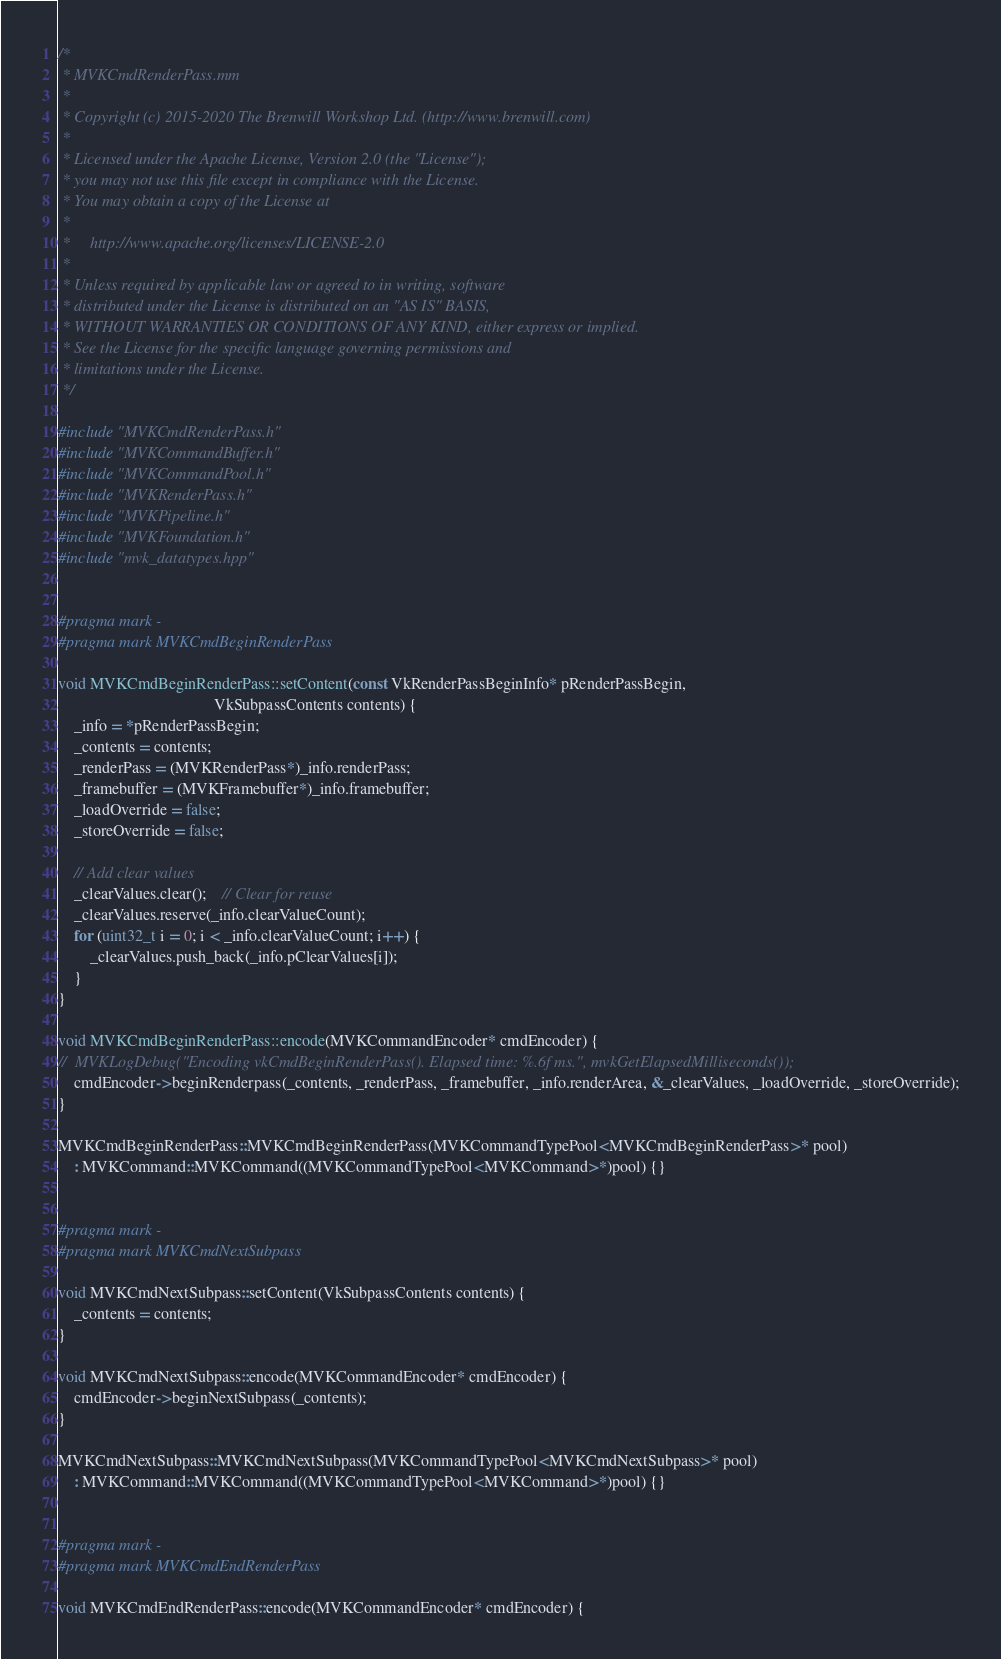Convert code to text. <code><loc_0><loc_0><loc_500><loc_500><_ObjectiveC_>/*
 * MVKCmdRenderPass.mm
 *
 * Copyright (c) 2015-2020 The Brenwill Workshop Ltd. (http://www.brenwill.com)
 *
 * Licensed under the Apache License, Version 2.0 (the "License");
 * you may not use this file except in compliance with the License.
 * You may obtain a copy of the License at
 * 
 *     http://www.apache.org/licenses/LICENSE-2.0
 * 
 * Unless required by applicable law or agreed to in writing, software
 * distributed under the License is distributed on an "AS IS" BASIS,
 * WITHOUT WARRANTIES OR CONDITIONS OF ANY KIND, either express or implied.
 * See the License for the specific language governing permissions and
 * limitations under the License.
 */

#include "MVKCmdRenderPass.h"
#include "MVKCommandBuffer.h"
#include "MVKCommandPool.h"
#include "MVKRenderPass.h"
#include "MVKPipeline.h"
#include "MVKFoundation.h"
#include "mvk_datatypes.hpp"


#pragma mark -
#pragma mark MVKCmdBeginRenderPass

void MVKCmdBeginRenderPass::setContent(const VkRenderPassBeginInfo* pRenderPassBegin,
									   VkSubpassContents contents) {
	_info = *pRenderPassBegin;
	_contents = contents;
	_renderPass = (MVKRenderPass*)_info.renderPass;
	_framebuffer = (MVKFramebuffer*)_info.framebuffer;
    _loadOverride = false;
    _storeOverride = false;

	// Add clear values
	_clearValues.clear();	// Clear for reuse
	_clearValues.reserve(_info.clearValueCount);
	for (uint32_t i = 0; i < _info.clearValueCount; i++) {
		_clearValues.push_back(_info.pClearValues[i]);
	}
}

void MVKCmdBeginRenderPass::encode(MVKCommandEncoder* cmdEncoder) {
//	MVKLogDebug("Encoding vkCmdBeginRenderPass(). Elapsed time: %.6f ms.", mvkGetElapsedMilliseconds());
	cmdEncoder->beginRenderpass(_contents, _renderPass, _framebuffer, _info.renderArea, &_clearValues, _loadOverride, _storeOverride);
}

MVKCmdBeginRenderPass::MVKCmdBeginRenderPass(MVKCommandTypePool<MVKCmdBeginRenderPass>* pool)
	: MVKCommand::MVKCommand((MVKCommandTypePool<MVKCommand>*)pool) {}


#pragma mark -
#pragma mark MVKCmdNextSubpass

void MVKCmdNextSubpass::setContent(VkSubpassContents contents) {
	_contents = contents;
}

void MVKCmdNextSubpass::encode(MVKCommandEncoder* cmdEncoder) {
	cmdEncoder->beginNextSubpass(_contents);
}

MVKCmdNextSubpass::MVKCmdNextSubpass(MVKCommandTypePool<MVKCmdNextSubpass>* pool)
	: MVKCommand::MVKCommand((MVKCommandTypePool<MVKCommand>*)pool) {}


#pragma mark -
#pragma mark MVKCmdEndRenderPass

void MVKCmdEndRenderPass::encode(MVKCommandEncoder* cmdEncoder) {</code> 